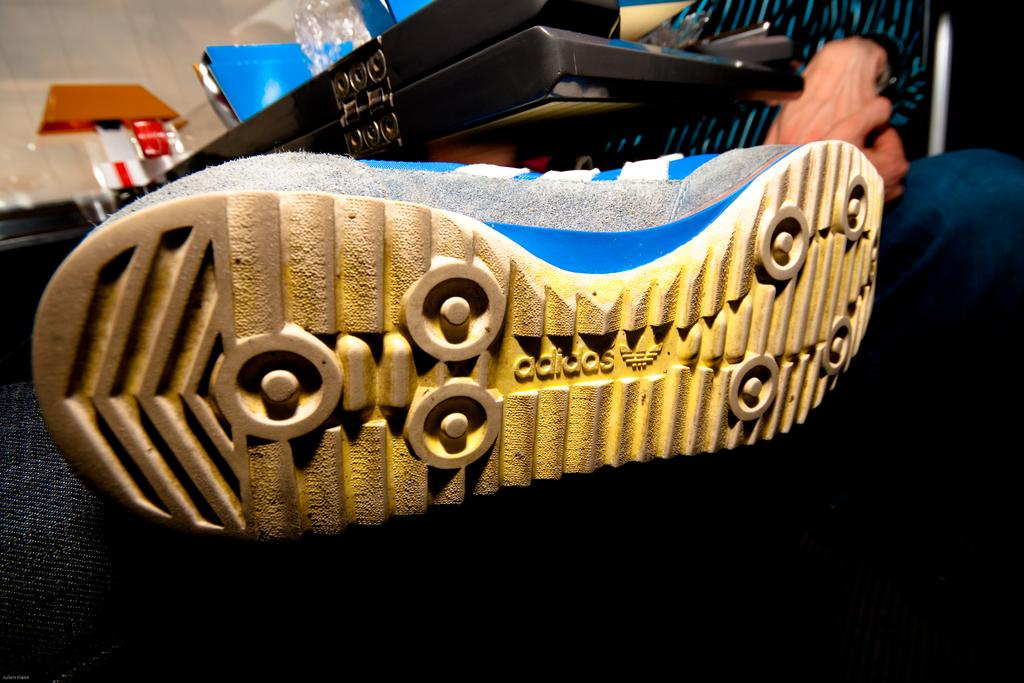What object is located in the front of the image? There is a shoe in the front of the image. What can be found on the tray in the image? There is a tray with cardboard and a cover in the image. Can you describe the person behind the tray? There appears to be a person behind the tray, but their appearance or actions are not clear from the image. What type of industry is depicted in the image? There is no industry depicted in the image; it features a shoe, a tray with cardboard, and a person behind the tray. Can you hear the person behind the tray speaking in the image? The image is silent, so it is not possible to hear the person behind the tray speaking. 